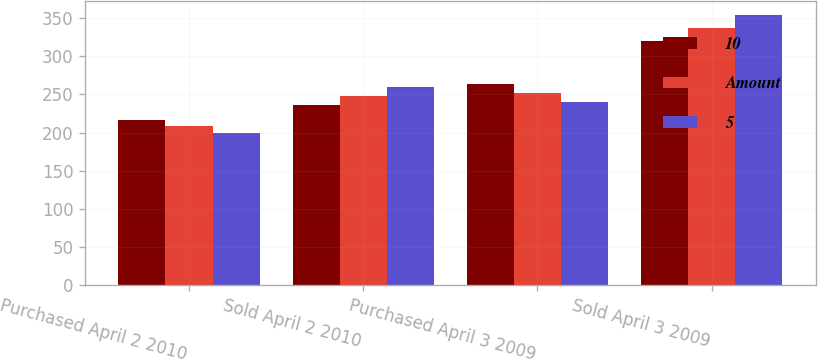<chart> <loc_0><loc_0><loc_500><loc_500><stacked_bar_chart><ecel><fcel>Purchased April 2 2010<fcel>Sold April 2 2010<fcel>Purchased April 3 2009<fcel>Sold April 3 2009<nl><fcel>10<fcel>217<fcel>236<fcel>264<fcel>320<nl><fcel>Amount<fcel>209<fcel>248<fcel>252<fcel>337<nl><fcel>5<fcel>199<fcel>260<fcel>240<fcel>355<nl></chart> 